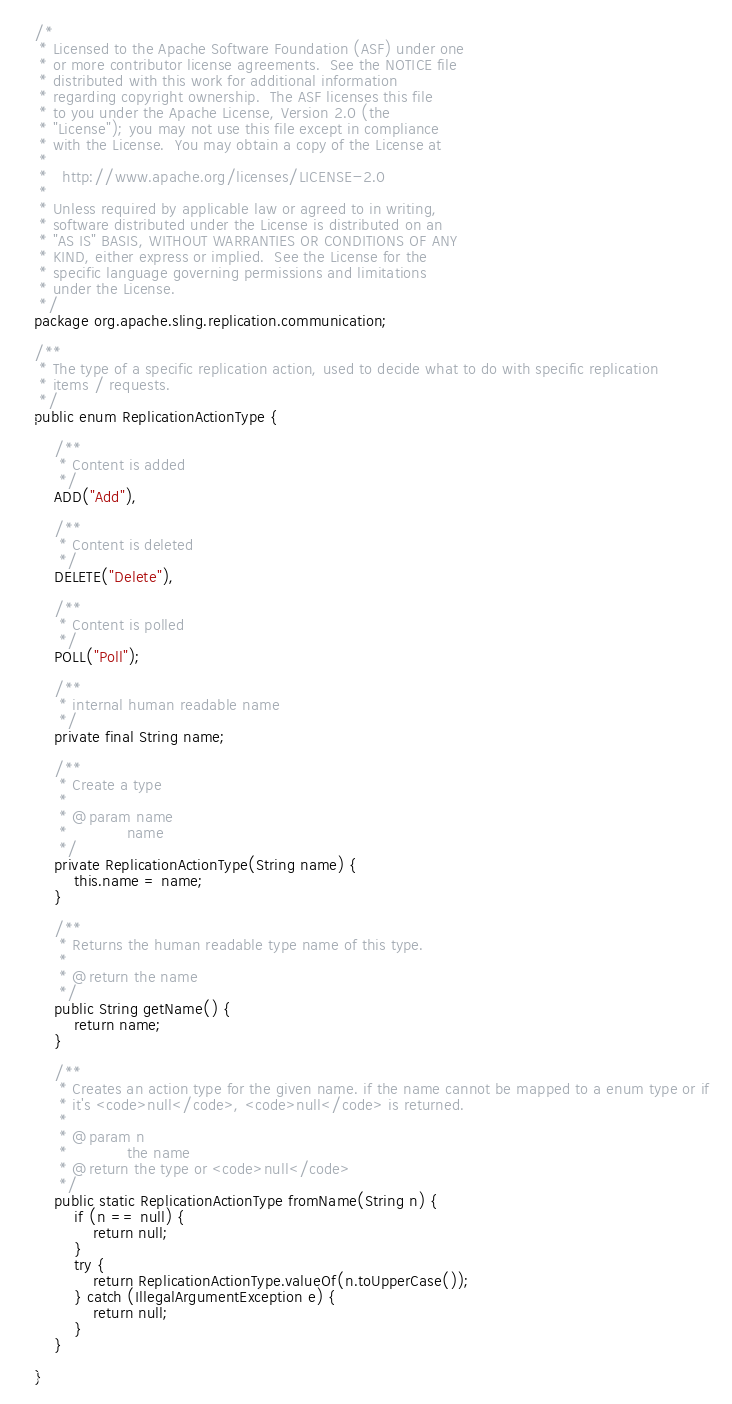Convert code to text. <code><loc_0><loc_0><loc_500><loc_500><_Java_>/*
 * Licensed to the Apache Software Foundation (ASF) under one
 * or more contributor license agreements.  See the NOTICE file
 * distributed with this work for additional information
 * regarding copyright ownership.  The ASF licenses this file
 * to you under the Apache License, Version 2.0 (the
 * "License"); you may not use this file except in compliance
 * with the License.  You may obtain a copy of the License at
 *
 *   http://www.apache.org/licenses/LICENSE-2.0
 *
 * Unless required by applicable law or agreed to in writing,
 * software distributed under the License is distributed on an
 * "AS IS" BASIS, WITHOUT WARRANTIES OR CONDITIONS OF ANY
 * KIND, either express or implied.  See the License for the
 * specific language governing permissions and limitations
 * under the License.
 */
package org.apache.sling.replication.communication;

/**
 * The type of a specific replication action, used to decide what to do with specific replication
 * items / requests.
 */
public enum ReplicationActionType {

    /**
     * Content is added
     */
    ADD("Add"),

    /**
     * Content is deleted
     */
    DELETE("Delete"),

    /**
     * Content is polled
     */
    POLL("Poll");

    /**
     * internal human readable name
     */
    private final String name;

    /**
     * Create a type
     * 
     * @param name
     *            name
     */
    private ReplicationActionType(String name) {
        this.name = name;
    }

    /**
     * Returns the human readable type name of this type.
     * 
     * @return the name
     */
    public String getName() {
        return name;
    }

    /**
     * Creates an action type for the given name. if the name cannot be mapped to a enum type or if
     * it's <code>null</code>, <code>null</code> is returned.
     * 
     * @param n
     *            the name
     * @return the type or <code>null</code>
     */
    public static ReplicationActionType fromName(String n) {
        if (n == null) {
            return null;
        }
        try {
            return ReplicationActionType.valueOf(n.toUpperCase());
        } catch (IllegalArgumentException e) {
            return null;
        }
    }

}
</code> 